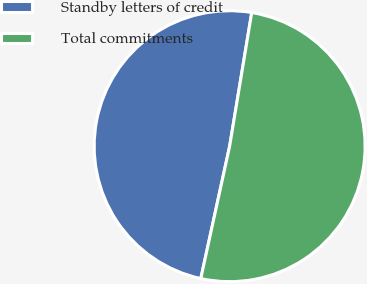Convert chart. <chart><loc_0><loc_0><loc_500><loc_500><pie_chart><fcel>Standby letters of credit<fcel>Total commitments<nl><fcel>49.19%<fcel>50.81%<nl></chart> 